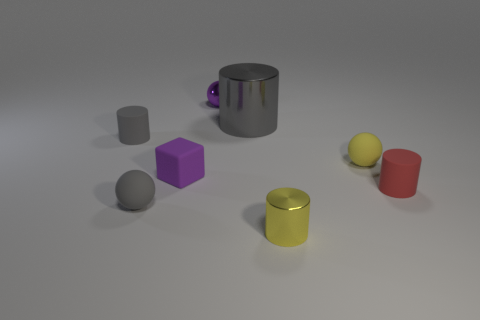There is a tiny ball that is behind the tiny matte cylinder behind the yellow ball; how many shiny objects are to the right of it?
Provide a short and direct response. 2. There is another gray thing that is the same shape as the big metallic object; what is it made of?
Ensure brevity in your answer.  Rubber. There is a small cylinder that is both behind the small metallic cylinder and on the right side of the big cylinder; what material is it?
Provide a succinct answer. Rubber. Are there fewer small gray matte balls on the right side of the purple matte block than cylinders on the right side of the small gray cylinder?
Make the answer very short. Yes. How many other things are there of the same size as the purple sphere?
Your answer should be very brief. 6. The small gray thing in front of the thing that is to the left of the tiny rubber sphere that is to the left of the yellow shiny thing is what shape?
Provide a short and direct response. Sphere. How many red things are cubes or tiny rubber spheres?
Provide a succinct answer. 0. What number of gray shiny cylinders are in front of the small shiny object in front of the tiny gray matte cylinder?
Offer a very short reply. 0. There is a purple object that is made of the same material as the small yellow cylinder; what is its shape?
Keep it short and to the point. Sphere. Does the small block have the same color as the tiny shiny ball?
Your answer should be compact. Yes. 